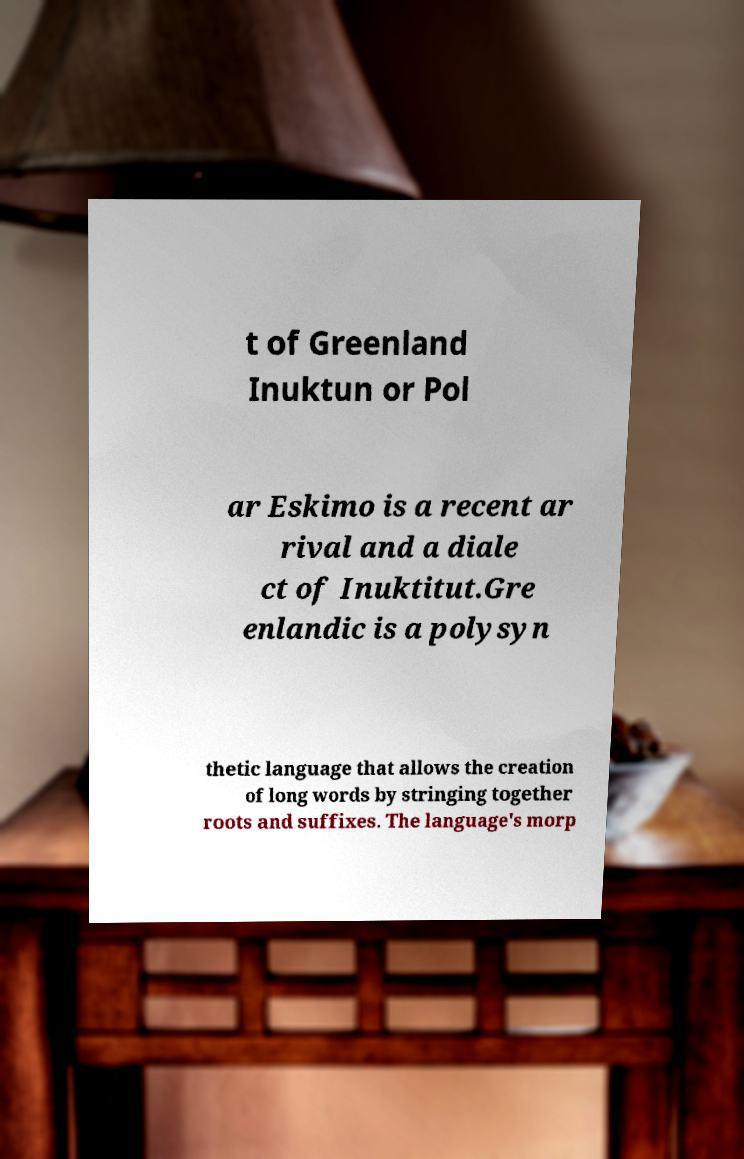Can you accurately transcribe the text from the provided image for me? t of Greenland Inuktun or Pol ar Eskimo is a recent ar rival and a diale ct of Inuktitut.Gre enlandic is a polysyn thetic language that allows the creation of long words by stringing together roots and suffixes. The language's morp 